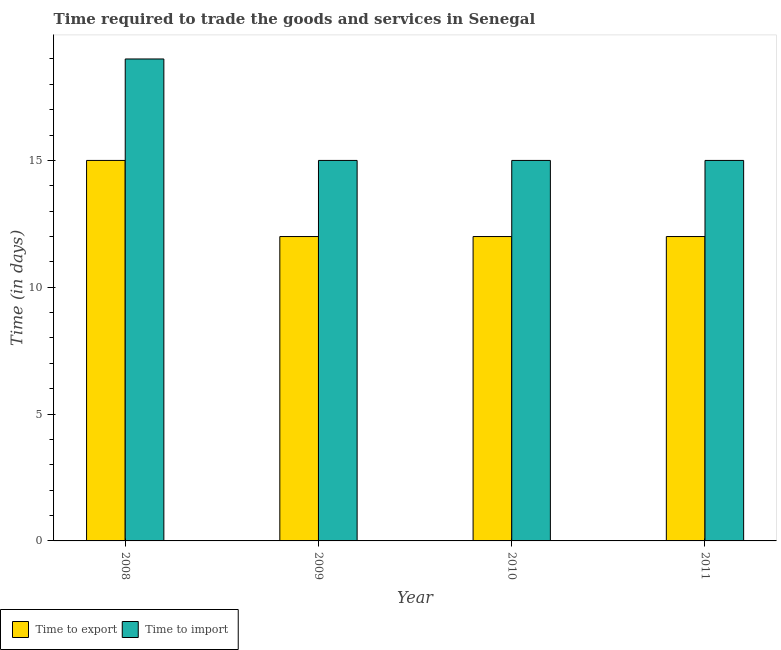How many different coloured bars are there?
Your response must be concise. 2. How many groups of bars are there?
Give a very brief answer. 4. How many bars are there on the 3rd tick from the left?
Your answer should be very brief. 2. How many bars are there on the 4th tick from the right?
Offer a terse response. 2. What is the label of the 1st group of bars from the left?
Provide a succinct answer. 2008. What is the time to import in 2010?
Provide a succinct answer. 15. Across all years, what is the maximum time to import?
Your response must be concise. 19. Across all years, what is the minimum time to import?
Your response must be concise. 15. In which year was the time to import maximum?
Your answer should be very brief. 2008. In which year was the time to export minimum?
Your answer should be compact. 2009. What is the total time to import in the graph?
Offer a terse response. 64. What is the difference between the time to export in 2008 and that in 2009?
Ensure brevity in your answer.  3. What is the difference between the time to import in 2011 and the time to export in 2008?
Offer a very short reply. -4. What is the average time to export per year?
Your answer should be very brief. 12.75. In the year 2009, what is the difference between the time to import and time to export?
Offer a very short reply. 0. Is the time to import in 2008 less than that in 2009?
Your response must be concise. No. What is the difference between the highest and the lowest time to import?
Offer a terse response. 4. In how many years, is the time to import greater than the average time to import taken over all years?
Provide a short and direct response. 1. What does the 2nd bar from the left in 2010 represents?
Ensure brevity in your answer.  Time to import. What does the 2nd bar from the right in 2009 represents?
Provide a short and direct response. Time to export. How many bars are there?
Your response must be concise. 8. Are all the bars in the graph horizontal?
Provide a succinct answer. No. How many years are there in the graph?
Make the answer very short. 4. Are the values on the major ticks of Y-axis written in scientific E-notation?
Your response must be concise. No. Does the graph contain grids?
Provide a succinct answer. No. Where does the legend appear in the graph?
Your response must be concise. Bottom left. How many legend labels are there?
Your answer should be compact. 2. How are the legend labels stacked?
Provide a short and direct response. Horizontal. What is the title of the graph?
Your response must be concise. Time required to trade the goods and services in Senegal. What is the label or title of the X-axis?
Your answer should be compact. Year. What is the label or title of the Y-axis?
Give a very brief answer. Time (in days). What is the Time (in days) of Time to export in 2009?
Offer a very short reply. 12. What is the Time (in days) of Time to import in 2010?
Ensure brevity in your answer.  15. What is the Time (in days) in Time to export in 2011?
Give a very brief answer. 12. Across all years, what is the maximum Time (in days) of Time to import?
Make the answer very short. 19. Across all years, what is the minimum Time (in days) of Time to export?
Offer a very short reply. 12. Across all years, what is the minimum Time (in days) of Time to import?
Provide a succinct answer. 15. What is the total Time (in days) of Time to export in the graph?
Your answer should be very brief. 51. What is the difference between the Time (in days) in Time to export in 2008 and that in 2010?
Provide a short and direct response. 3. What is the difference between the Time (in days) in Time to import in 2008 and that in 2010?
Provide a short and direct response. 4. What is the difference between the Time (in days) of Time to import in 2009 and that in 2010?
Your answer should be very brief. 0. What is the difference between the Time (in days) in Time to export in 2008 and the Time (in days) in Time to import in 2009?
Provide a short and direct response. 0. What is the difference between the Time (in days) in Time to export in 2008 and the Time (in days) in Time to import in 2010?
Provide a succinct answer. 0. What is the difference between the Time (in days) of Time to export in 2009 and the Time (in days) of Time to import in 2010?
Offer a terse response. -3. What is the difference between the Time (in days) in Time to export in 2010 and the Time (in days) in Time to import in 2011?
Offer a terse response. -3. What is the average Time (in days) of Time to export per year?
Provide a succinct answer. 12.75. What is the average Time (in days) in Time to import per year?
Offer a very short reply. 16. In the year 2008, what is the difference between the Time (in days) of Time to export and Time (in days) of Time to import?
Your answer should be very brief. -4. In the year 2009, what is the difference between the Time (in days) in Time to export and Time (in days) in Time to import?
Your response must be concise. -3. In the year 2010, what is the difference between the Time (in days) in Time to export and Time (in days) in Time to import?
Offer a terse response. -3. What is the ratio of the Time (in days) in Time to import in 2008 to that in 2009?
Ensure brevity in your answer.  1.27. What is the ratio of the Time (in days) in Time to import in 2008 to that in 2010?
Provide a short and direct response. 1.27. What is the ratio of the Time (in days) of Time to export in 2008 to that in 2011?
Offer a terse response. 1.25. What is the ratio of the Time (in days) in Time to import in 2008 to that in 2011?
Provide a short and direct response. 1.27. What is the ratio of the Time (in days) of Time to export in 2010 to that in 2011?
Ensure brevity in your answer.  1. What is the ratio of the Time (in days) in Time to import in 2010 to that in 2011?
Keep it short and to the point. 1. What is the difference between the highest and the second highest Time (in days) in Time to import?
Your response must be concise. 4. What is the difference between the highest and the lowest Time (in days) of Time to export?
Give a very brief answer. 3. 